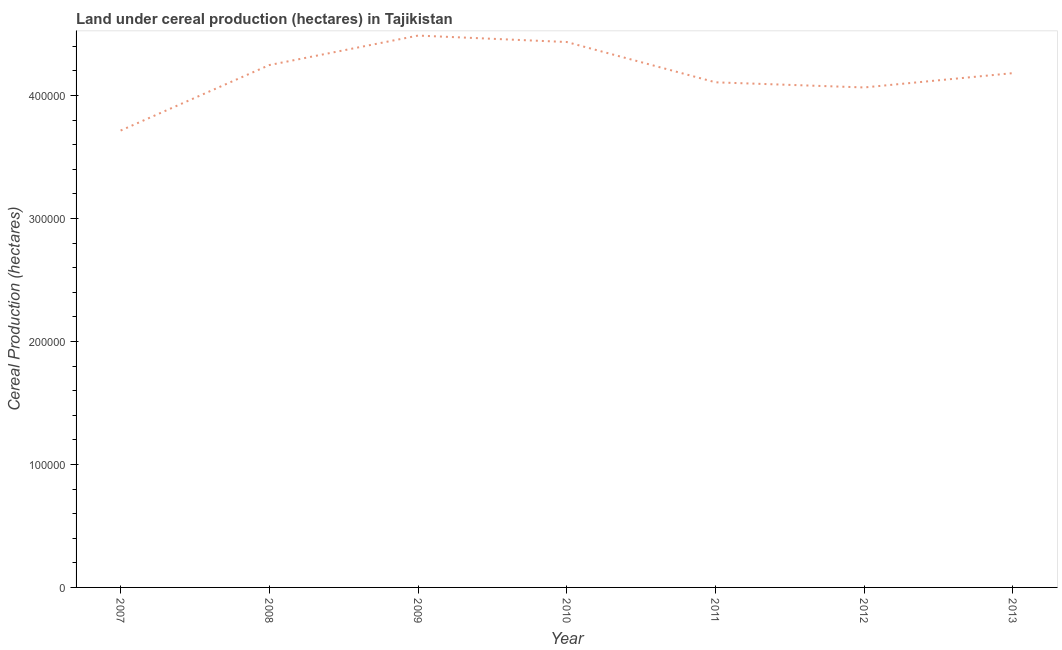What is the land under cereal production in 2007?
Make the answer very short. 3.72e+05. Across all years, what is the maximum land under cereal production?
Offer a terse response. 4.49e+05. Across all years, what is the minimum land under cereal production?
Your response must be concise. 3.72e+05. In which year was the land under cereal production maximum?
Offer a very short reply. 2009. What is the sum of the land under cereal production?
Offer a terse response. 2.92e+06. What is the difference between the land under cereal production in 2010 and 2013?
Your response must be concise. 2.53e+04. What is the average land under cereal production per year?
Keep it short and to the point. 4.18e+05. What is the median land under cereal production?
Ensure brevity in your answer.  4.18e+05. In how many years, is the land under cereal production greater than 220000 hectares?
Provide a short and direct response. 7. What is the ratio of the land under cereal production in 2009 to that in 2012?
Provide a short and direct response. 1.1. Is the land under cereal production in 2008 less than that in 2010?
Keep it short and to the point. Yes. What is the difference between the highest and the second highest land under cereal production?
Make the answer very short. 5244.7. What is the difference between the highest and the lowest land under cereal production?
Your answer should be compact. 7.72e+04. In how many years, is the land under cereal production greater than the average land under cereal production taken over all years?
Your answer should be compact. 4. Does the land under cereal production monotonically increase over the years?
Offer a terse response. No. How many lines are there?
Your answer should be very brief. 1. What is the title of the graph?
Ensure brevity in your answer.  Land under cereal production (hectares) in Tajikistan. What is the label or title of the X-axis?
Provide a succinct answer. Year. What is the label or title of the Y-axis?
Your answer should be compact. Cereal Production (hectares). What is the Cereal Production (hectares) of 2007?
Your answer should be compact. 3.72e+05. What is the Cereal Production (hectares) of 2008?
Offer a very short reply. 4.25e+05. What is the Cereal Production (hectares) in 2009?
Provide a short and direct response. 4.49e+05. What is the Cereal Production (hectares) in 2010?
Ensure brevity in your answer.  4.44e+05. What is the Cereal Production (hectares) in 2011?
Offer a very short reply. 4.11e+05. What is the Cereal Production (hectares) of 2012?
Provide a succinct answer. 4.07e+05. What is the Cereal Production (hectares) in 2013?
Make the answer very short. 4.18e+05. What is the difference between the Cereal Production (hectares) in 2007 and 2008?
Your answer should be compact. -5.33e+04. What is the difference between the Cereal Production (hectares) in 2007 and 2009?
Offer a terse response. -7.72e+04. What is the difference between the Cereal Production (hectares) in 2007 and 2010?
Ensure brevity in your answer.  -7.20e+04. What is the difference between the Cereal Production (hectares) in 2007 and 2011?
Offer a very short reply. -3.92e+04. What is the difference between the Cereal Production (hectares) in 2007 and 2012?
Make the answer very short. -3.50e+04. What is the difference between the Cereal Production (hectares) in 2007 and 2013?
Keep it short and to the point. -4.67e+04. What is the difference between the Cereal Production (hectares) in 2008 and 2009?
Provide a succinct answer. -2.40e+04. What is the difference between the Cereal Production (hectares) in 2008 and 2010?
Provide a short and direct response. -1.87e+04. What is the difference between the Cereal Production (hectares) in 2008 and 2011?
Keep it short and to the point. 1.40e+04. What is the difference between the Cereal Production (hectares) in 2008 and 2012?
Your answer should be very brief. 1.82e+04. What is the difference between the Cereal Production (hectares) in 2008 and 2013?
Provide a succinct answer. 6574. What is the difference between the Cereal Production (hectares) in 2009 and 2010?
Provide a short and direct response. 5244.7. What is the difference between the Cereal Production (hectares) in 2009 and 2011?
Ensure brevity in your answer.  3.80e+04. What is the difference between the Cereal Production (hectares) in 2009 and 2012?
Your answer should be very brief. 4.22e+04. What is the difference between the Cereal Production (hectares) in 2009 and 2013?
Your answer should be very brief. 3.05e+04. What is the difference between the Cereal Production (hectares) in 2010 and 2011?
Your answer should be compact. 3.28e+04. What is the difference between the Cereal Production (hectares) in 2010 and 2012?
Your response must be concise. 3.69e+04. What is the difference between the Cereal Production (hectares) in 2010 and 2013?
Give a very brief answer. 2.53e+04. What is the difference between the Cereal Production (hectares) in 2011 and 2012?
Keep it short and to the point. 4181. What is the difference between the Cereal Production (hectares) in 2011 and 2013?
Make the answer very short. -7466. What is the difference between the Cereal Production (hectares) in 2012 and 2013?
Offer a very short reply. -1.16e+04. What is the ratio of the Cereal Production (hectares) in 2007 to that in 2008?
Offer a very short reply. 0.88. What is the ratio of the Cereal Production (hectares) in 2007 to that in 2009?
Provide a short and direct response. 0.83. What is the ratio of the Cereal Production (hectares) in 2007 to that in 2010?
Keep it short and to the point. 0.84. What is the ratio of the Cereal Production (hectares) in 2007 to that in 2011?
Provide a succinct answer. 0.91. What is the ratio of the Cereal Production (hectares) in 2007 to that in 2012?
Your answer should be very brief. 0.91. What is the ratio of the Cereal Production (hectares) in 2007 to that in 2013?
Ensure brevity in your answer.  0.89. What is the ratio of the Cereal Production (hectares) in 2008 to that in 2009?
Give a very brief answer. 0.95. What is the ratio of the Cereal Production (hectares) in 2008 to that in 2010?
Offer a terse response. 0.96. What is the ratio of the Cereal Production (hectares) in 2008 to that in 2011?
Your answer should be compact. 1.03. What is the ratio of the Cereal Production (hectares) in 2008 to that in 2012?
Ensure brevity in your answer.  1.04. What is the ratio of the Cereal Production (hectares) in 2009 to that in 2010?
Provide a short and direct response. 1.01. What is the ratio of the Cereal Production (hectares) in 2009 to that in 2011?
Give a very brief answer. 1.09. What is the ratio of the Cereal Production (hectares) in 2009 to that in 2012?
Give a very brief answer. 1.1. What is the ratio of the Cereal Production (hectares) in 2009 to that in 2013?
Provide a succinct answer. 1.07. What is the ratio of the Cereal Production (hectares) in 2010 to that in 2012?
Give a very brief answer. 1.09. What is the ratio of the Cereal Production (hectares) in 2010 to that in 2013?
Make the answer very short. 1.06. What is the ratio of the Cereal Production (hectares) in 2011 to that in 2013?
Ensure brevity in your answer.  0.98. What is the ratio of the Cereal Production (hectares) in 2012 to that in 2013?
Give a very brief answer. 0.97. 